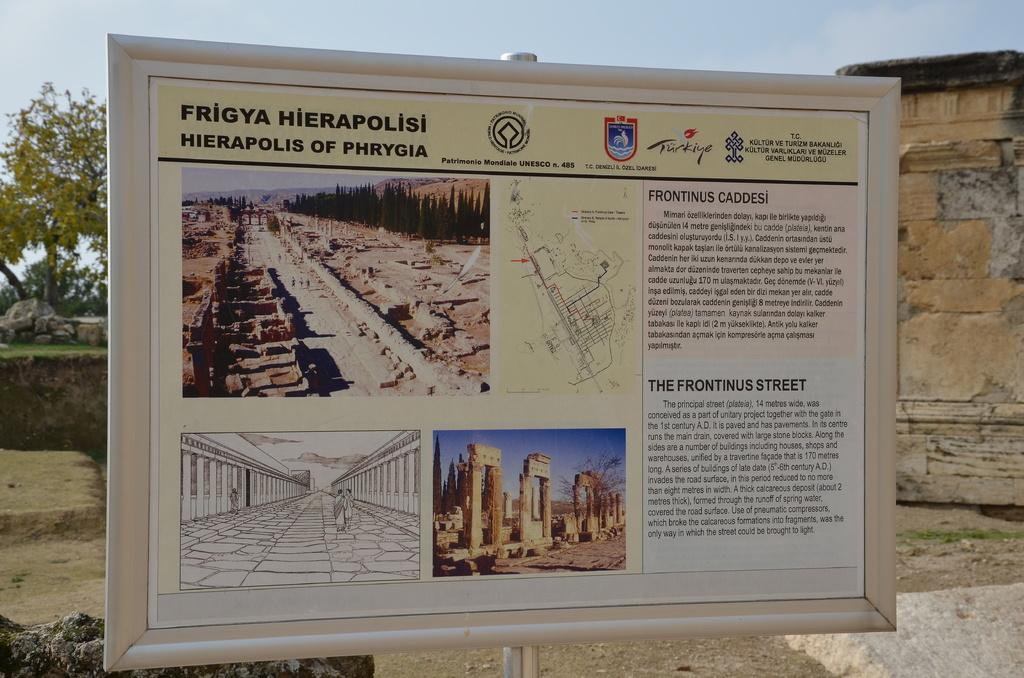<image>
Present a compact description of the photo's key features. A sign is titled Frigya Hierapolisi and has a blue sky behind it. 